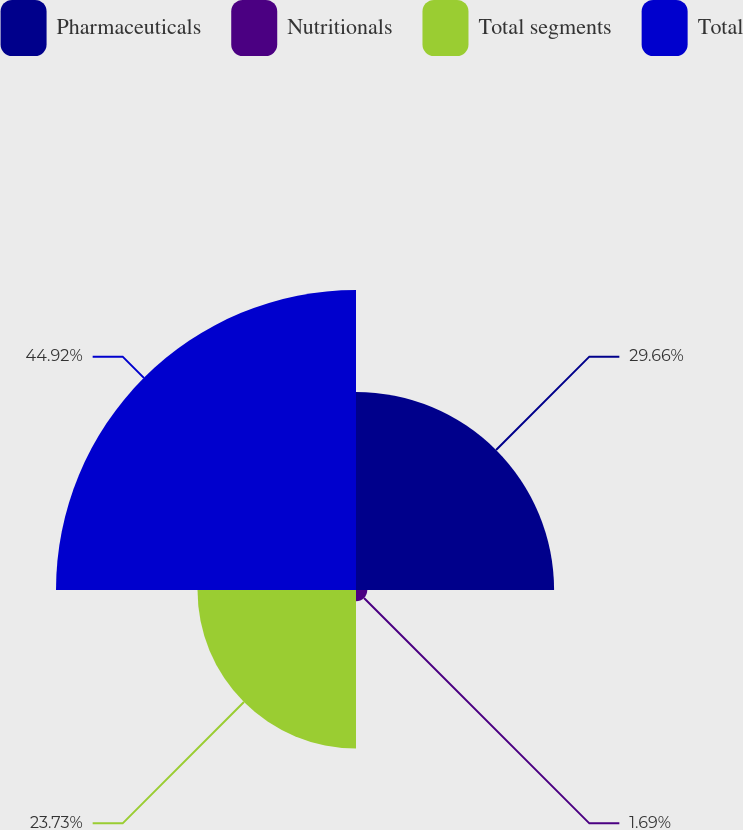Convert chart to OTSL. <chart><loc_0><loc_0><loc_500><loc_500><pie_chart><fcel>Pharmaceuticals<fcel>Nutritionals<fcel>Total segments<fcel>Total<nl><fcel>29.66%<fcel>1.69%<fcel>23.73%<fcel>44.92%<nl></chart> 